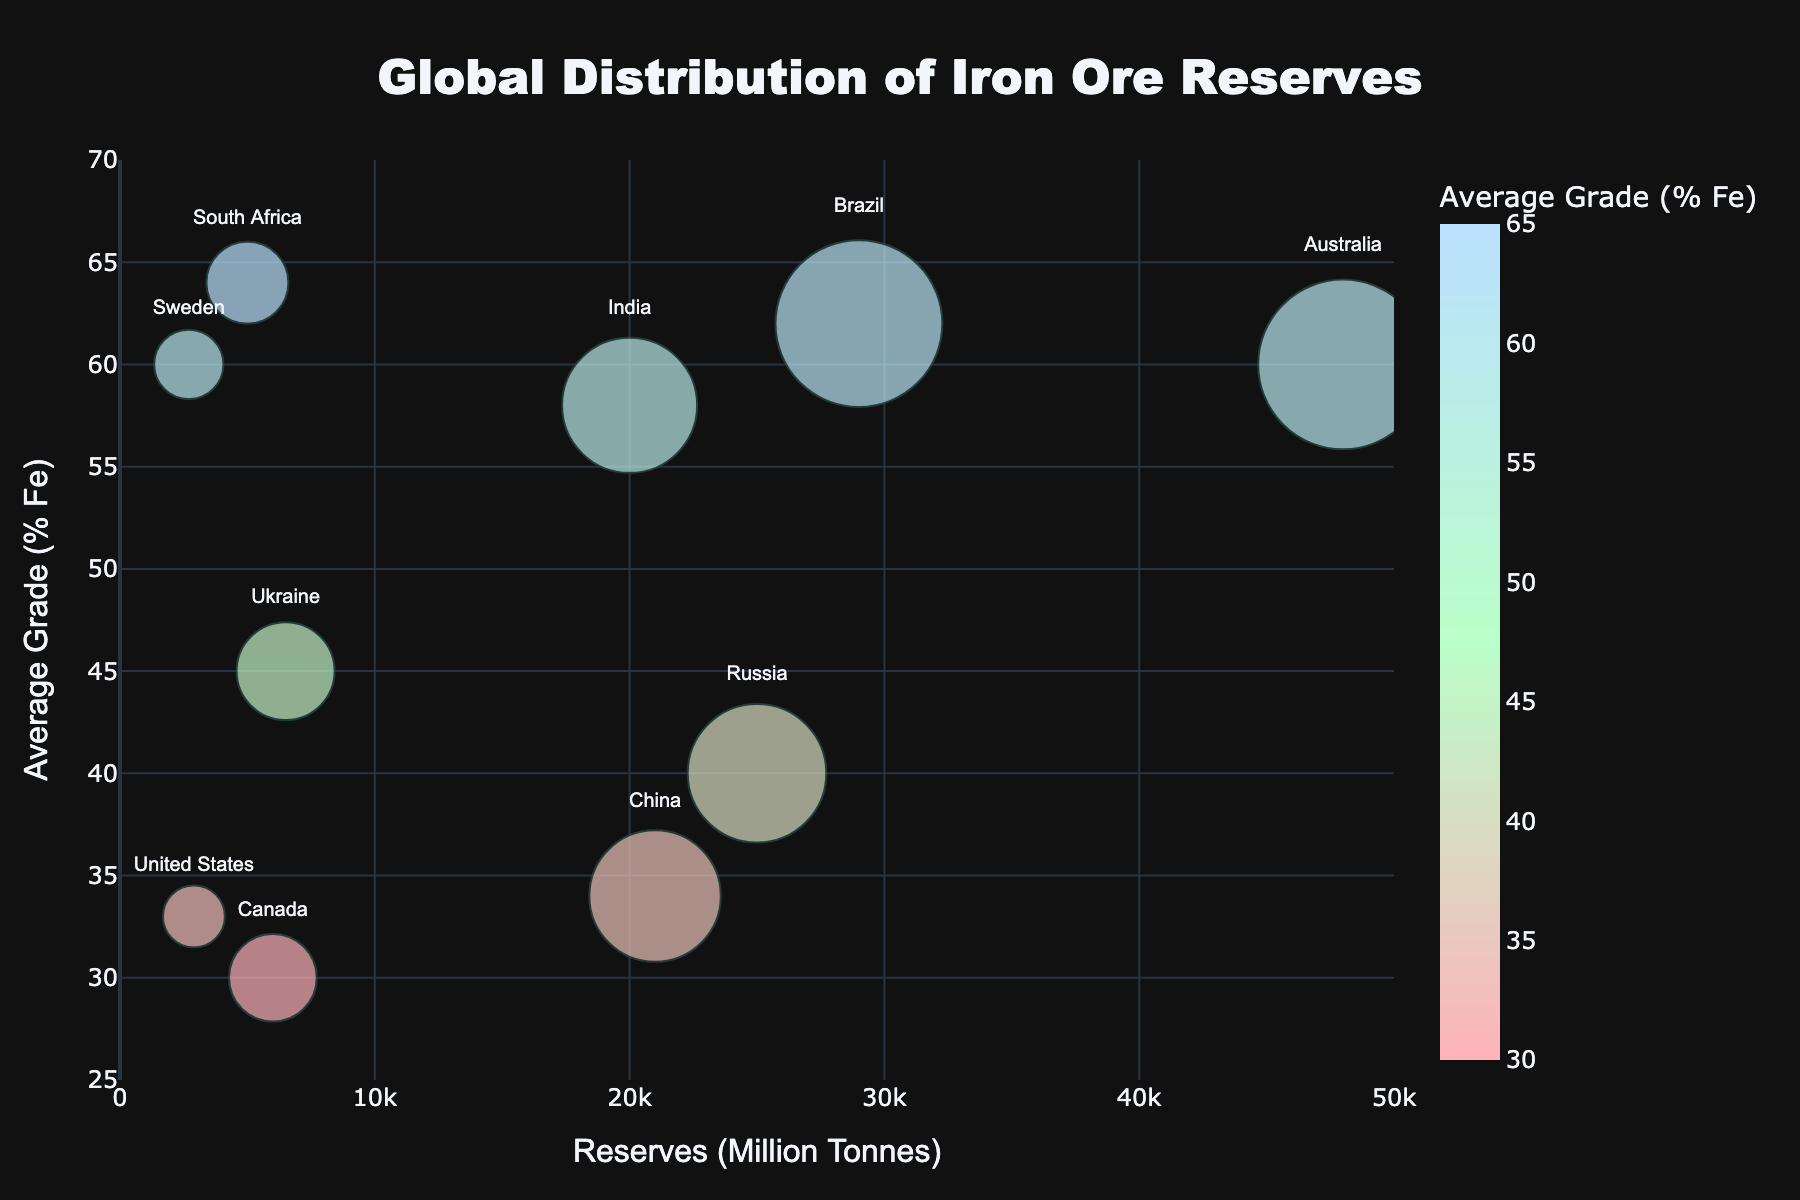What's the title of the figure? The title of the figure is centered at the top and is written in a larger font. It reads "Global Distribution of Iron Ore Reserves."
Answer: Global Distribution of Iron Ore Reserves Which country has the highest average grade of iron ore? By looking at the vertical axis labeled "Average Grade (% Fe)", the highest point corresponds to South Africa, which has an average grade of 64% Fe.
Answer: South Africa How many countries have iron ore reserves higher than 20,000 million tonnes? Referring to the horizontal axis titled "Reserves (Million Tonnes)", we count the bubbles to the right of the 20,000 mark. These countries are Australia, Brazil, Russia, China, and India, totaling 5 countries.
Answer: 5 Which country has the smallest bubble size, and what does it signify? The smallest bubble size is noted in the legend under "BubbleSize". This bubble belongs to the United States, signifying it has the smallest relative value for bubble size, which corresponds to some attribute measured in the data.
Answer: United States What is the bubble size for Sweden, and what might it represent? The bubble size for Sweden can be found by locating its bubble in the chart, which is notably smaller. The provided data shows Sweden's bubble size as 5. Bubble sizes generally represent relative quantities like production volume, exploration activity, or market share.
Answer: 5 Compare the iron ore reserves between Russia and India. Which country has more reserves and by how much? By checking the horizontal positions of the bubbles for Russia and India, Russia has 25,000 million tonnes, and India has 20,000 million tonnes. The difference between them is 25,000 - 20,000 = 5,000 million tonnes.
Answer: Russia by 5,000 million tonnes Which country has an average grade closest to 50% Fe? Referring to the vertical axis and locating the bubbles around the 50% mark, Ukraine has an average grade close to 50% Fe.
Answer: Ukraine What is the average iron ore grade of the top 3 countries with the highest reserves? The top three countries by reserves are Australia (48000), Brazil (29000), and Russia (25000). Their average grades are 60%, 62%, and 40%, respectively. The average grade is (60 + 62 + 40) / 3 ≈ 54%.
Answer: 54% Between Canada and the United States, which country has a higher average iron ore grade, and what are their grades? Canada and the United States have average iron ore grades of 30% and 33% Fe, respectively, based on their vertical positions in the chart. The United States has a higher grade.
Answer: United States (33%) vs. Canada (30%) How does the opacity of the bubbles impact the interpretation of overlapping data points? The bubbles are semi-transparent, allowing some visual overlap. This transparency helps distinguish overlapping bubbles, providing a clearer view of underlying data points. Transparent bubbles make it easier to identify the presence and characteristics of multiple data points in the same area.
Answer: Enhanced visibility of overlapping bubbles 